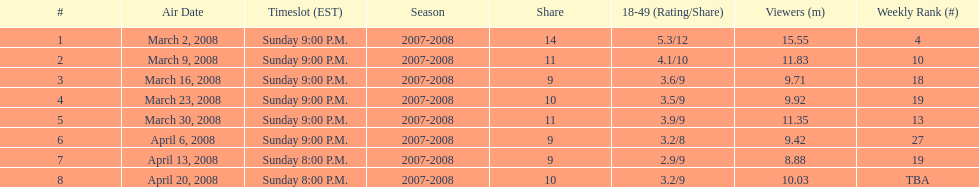How long did the program air for in days? 8. 